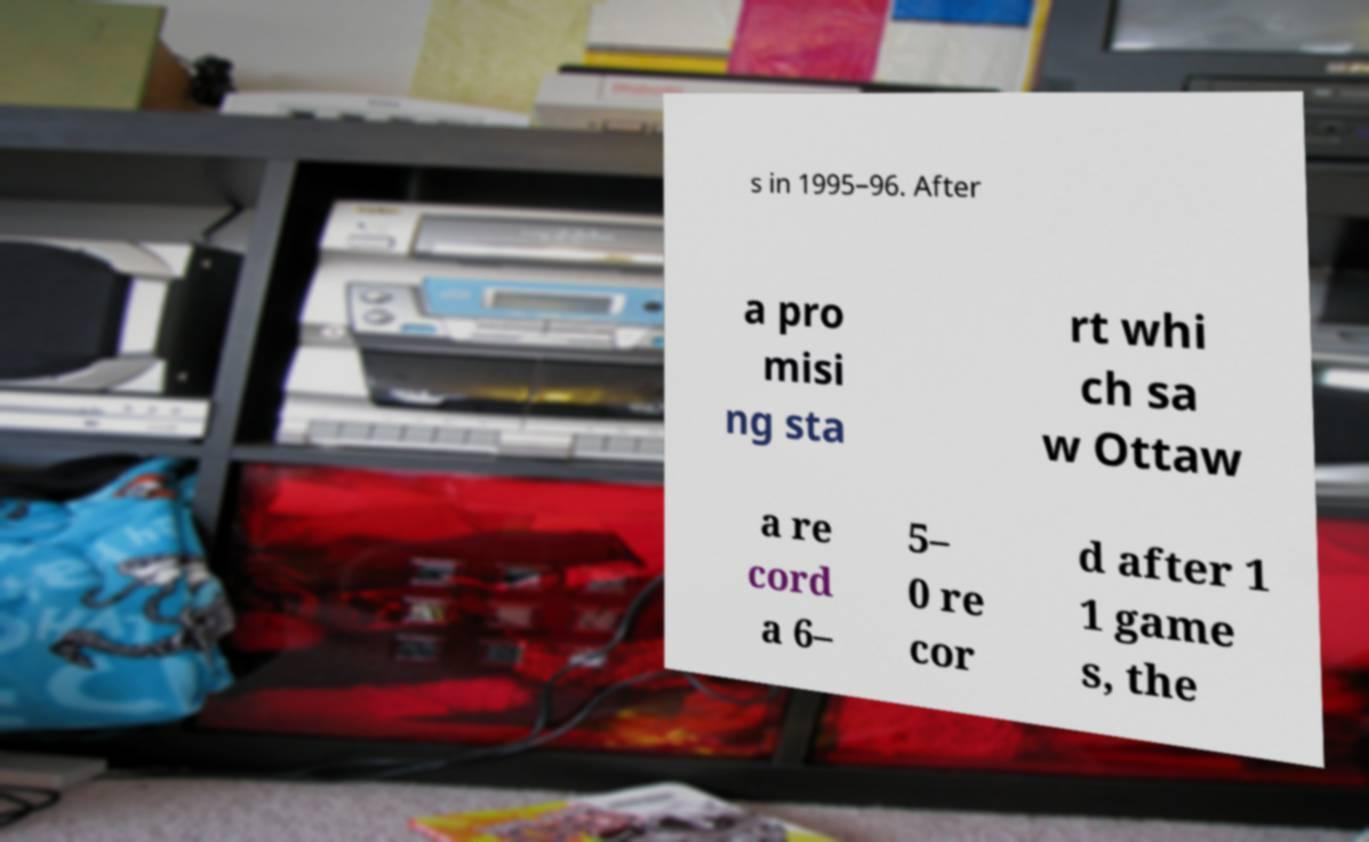There's text embedded in this image that I need extracted. Can you transcribe it verbatim? s in 1995–96. After a pro misi ng sta rt whi ch sa w Ottaw a re cord a 6– 5– 0 re cor d after 1 1 game s, the 